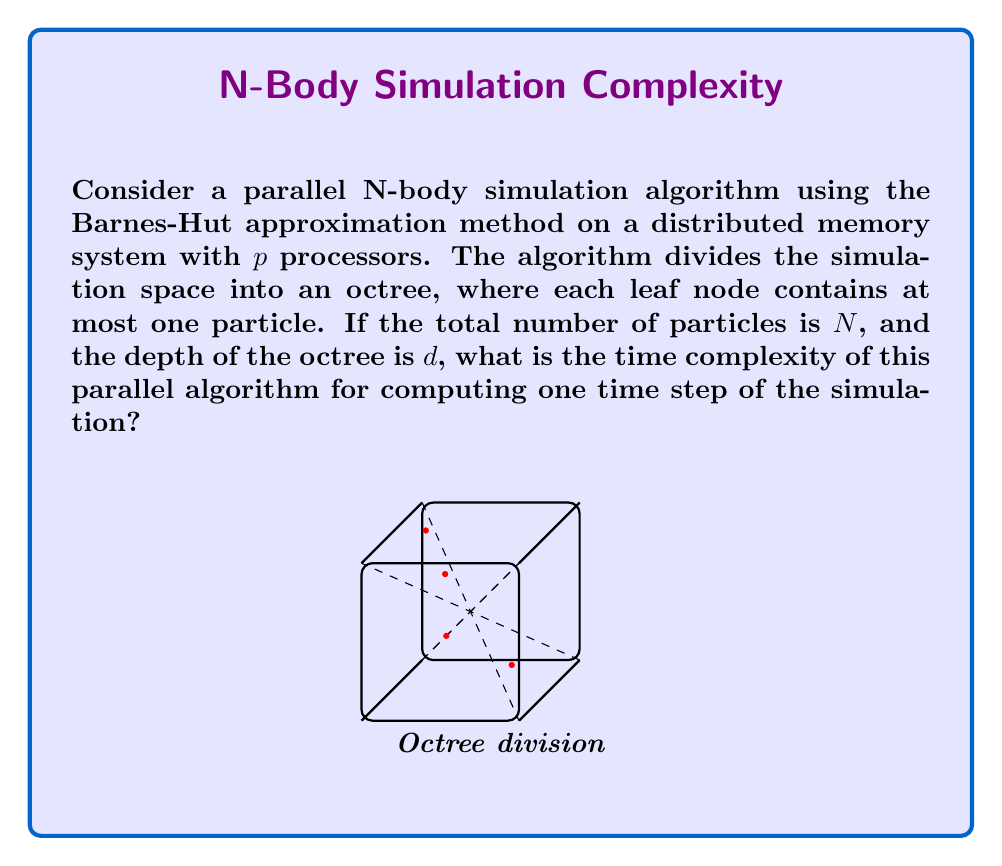Teach me how to tackle this problem. Let's analyze the time complexity step by step:

1) Octree Construction:
   - Sequential time: $O(N \log N)$
   - Parallel time: $O(\frac{N}{p} \log N)$

2) Force Calculation:
   - For each particle, we traverse the octree
   - Depth of octree: $d = O(\log N)$
   - Number of interactions per particle: $O(\log N)$
   - Total interactions: $O(N \log N)$
   - Parallel time: $O(\frac{N}{p} \log N)$

3) Position Update:
   - Sequential time: $O(N)$
   - Parallel time: $O(\frac{N}{p})$

4) Communication Overhead:
   - Each processor needs to communicate with others
   - Assuming all-to-all communication: $O(\log p)$

5) Load Balancing:
   - Assuming good load balancing, each processor handles $\frac{N}{p}$ particles

Total parallel time complexity:
$$T(N,p) = O(\frac{N}{p} \log N + \log p)$$

The $\frac{N}{p} \log N$ term dominates for large $N$, so we can simplify:

$$T(N,p) = O(\frac{N}{p} \log N)$$

This assumes $p \ll N$. If $p$ approaches $N$, the communication overhead becomes significant, and the efficiency decreases.
Answer: $O(\frac{N}{p} \log N)$ 